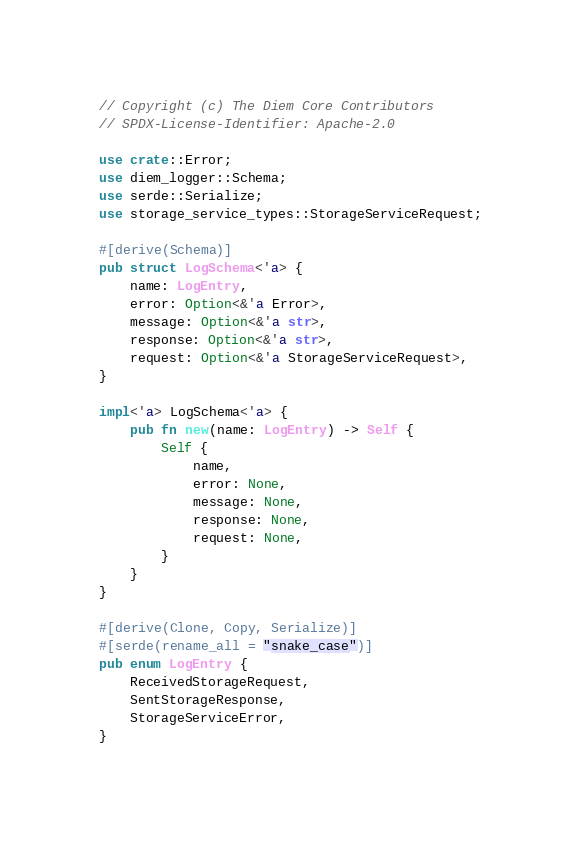<code> <loc_0><loc_0><loc_500><loc_500><_Rust_>// Copyright (c) The Diem Core Contributors
// SPDX-License-Identifier: Apache-2.0

use crate::Error;
use diem_logger::Schema;
use serde::Serialize;
use storage_service_types::StorageServiceRequest;

#[derive(Schema)]
pub struct LogSchema<'a> {
    name: LogEntry,
    error: Option<&'a Error>,
    message: Option<&'a str>,
    response: Option<&'a str>,
    request: Option<&'a StorageServiceRequest>,
}

impl<'a> LogSchema<'a> {
    pub fn new(name: LogEntry) -> Self {
        Self {
            name,
            error: None,
            message: None,
            response: None,
            request: None,
        }
    }
}

#[derive(Clone, Copy, Serialize)]
#[serde(rename_all = "snake_case")]
pub enum LogEntry {
    ReceivedStorageRequest,
    SentStorageResponse,
    StorageServiceError,
}
</code> 